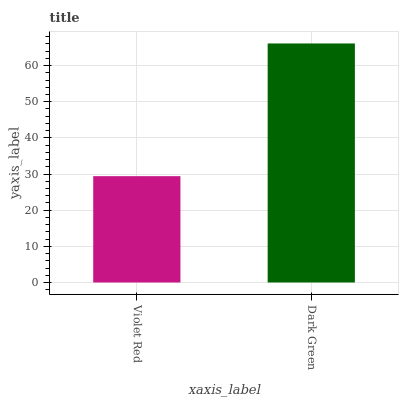Is Violet Red the minimum?
Answer yes or no. Yes. Is Dark Green the maximum?
Answer yes or no. Yes. Is Dark Green the minimum?
Answer yes or no. No. Is Dark Green greater than Violet Red?
Answer yes or no. Yes. Is Violet Red less than Dark Green?
Answer yes or no. Yes. Is Violet Red greater than Dark Green?
Answer yes or no. No. Is Dark Green less than Violet Red?
Answer yes or no. No. Is Dark Green the high median?
Answer yes or no. Yes. Is Violet Red the low median?
Answer yes or no. Yes. Is Violet Red the high median?
Answer yes or no. No. Is Dark Green the low median?
Answer yes or no. No. 